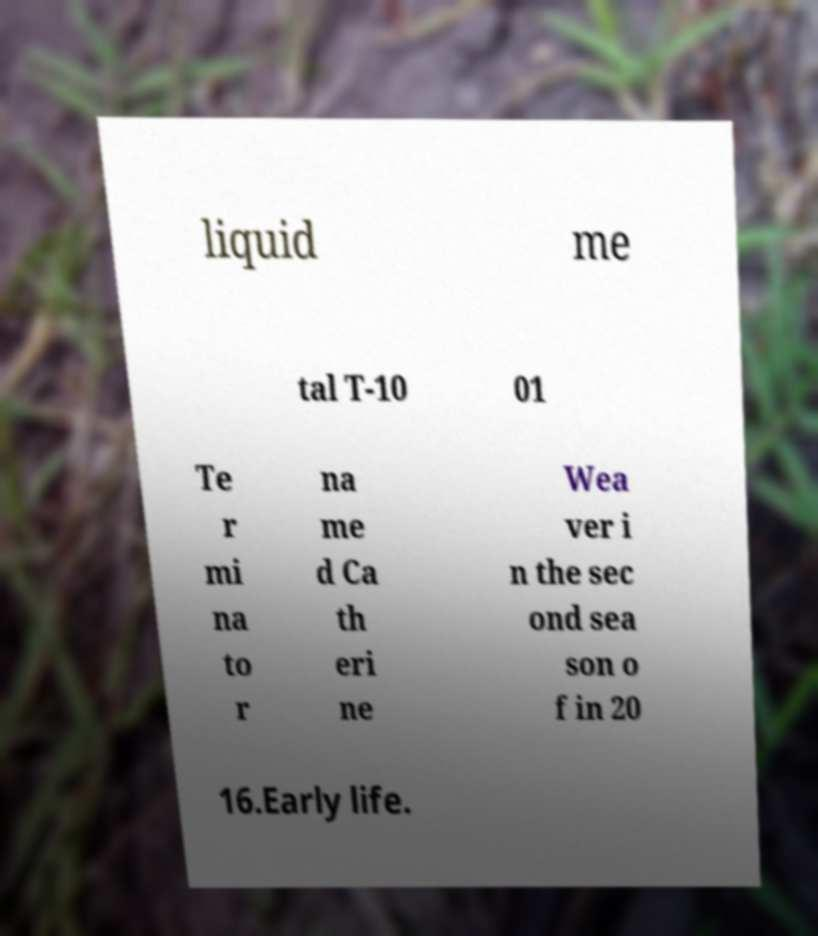Please read and relay the text visible in this image. What does it say? liquid me tal T-10 01 Te r mi na to r na me d Ca th eri ne Wea ver i n the sec ond sea son o f in 20 16.Early life. 